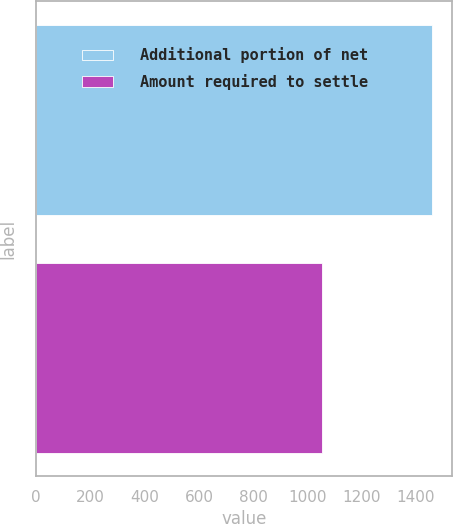Convert chart to OTSL. <chart><loc_0><loc_0><loc_500><loc_500><bar_chart><fcel>Additional portion of net<fcel>Amount required to settle<nl><fcel>1460<fcel>1054<nl></chart> 